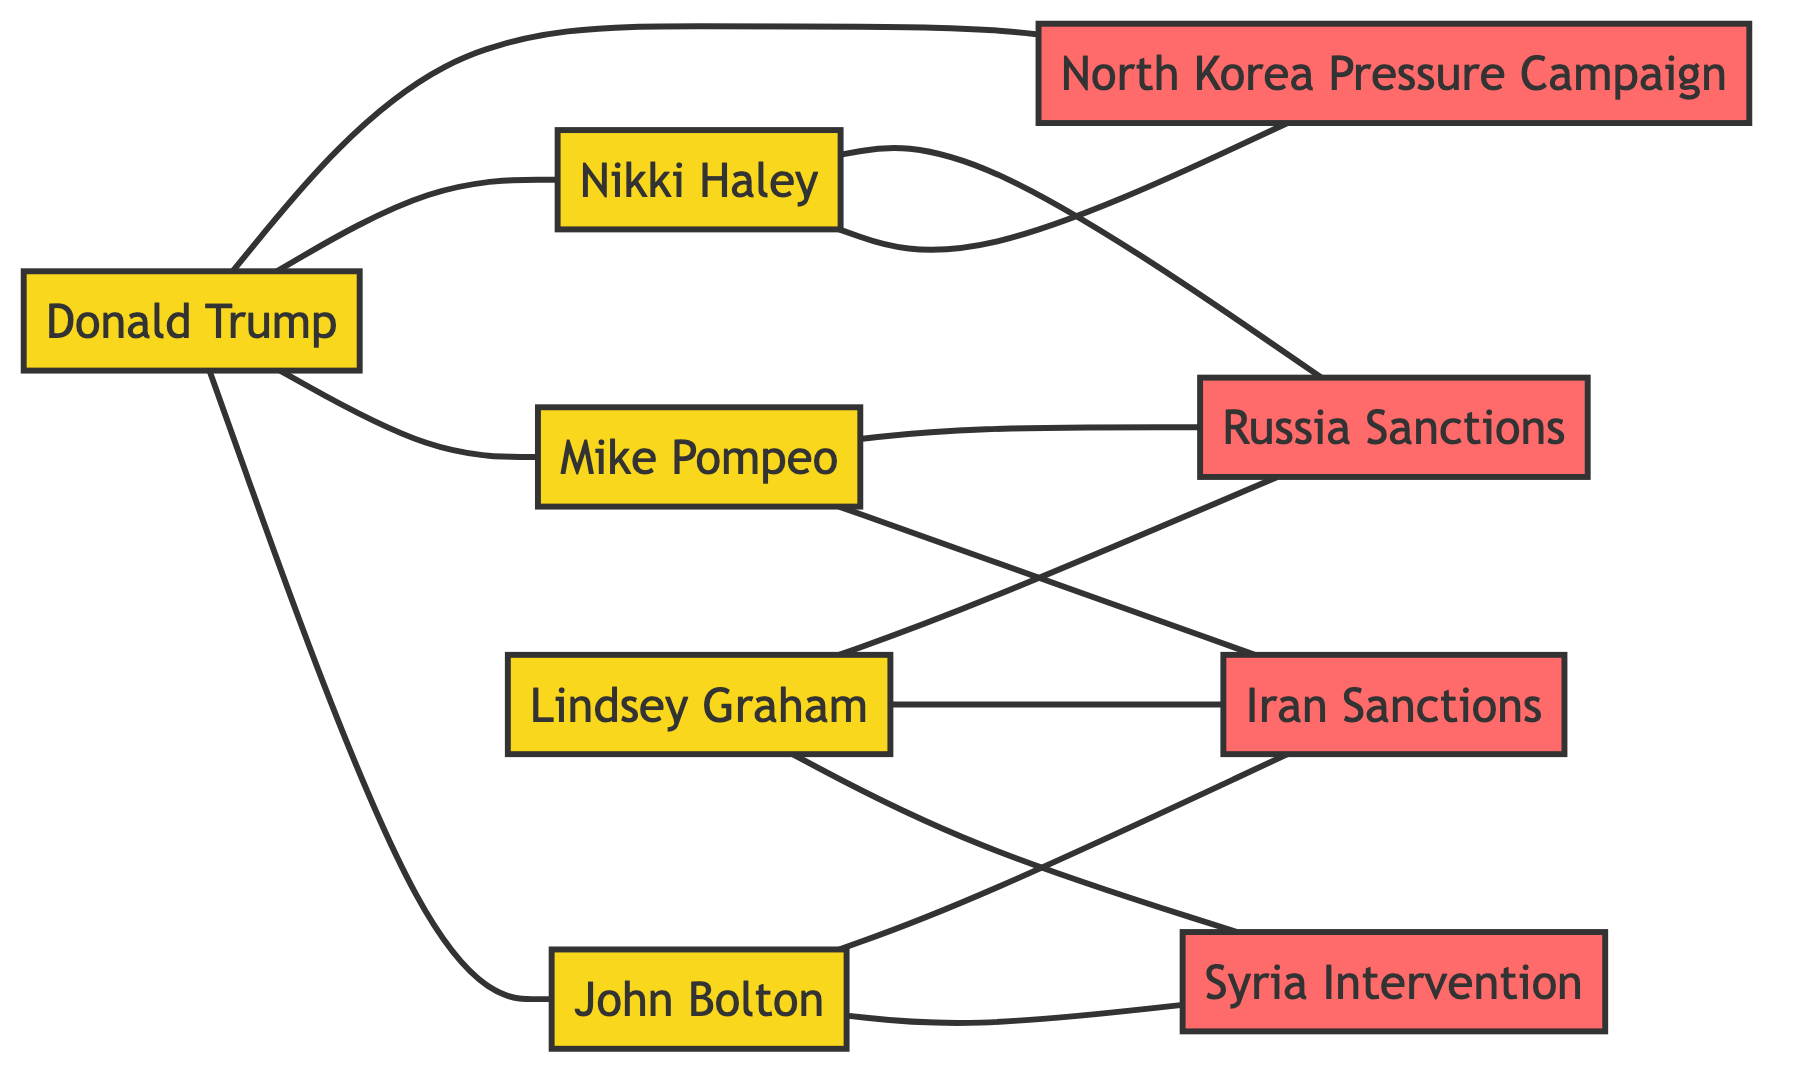What is the total number of nodes in the graph? The graph contains 8 nodes, which are 5 political figures and 3 policy decisions.
Answer: 8 Which political figure was appointed as US Ambassador to the UN? The edge connecting Donald Trump to Nikki Haley indicates that Nikki Haley was appointed as US Ambassador to the UN.
Answer: Nikki Haley How many policy decisions are linked to Lindsey Graham? Lindsey Graham is connected to Syria Intervention, Iran Sanctions, and Russia Sanctions, totaling 3 policy decisions.
Answer: 3 What relationship links John Bolton to the policy decision of Syria Intervention? John Bolton advocated for Syria Intervention, as indicated by the edge from John Bolton to Syria Intervention.
Answer: advocated for Which policy decisions did Mike Pompeo support? Mike Pompeo is linked to two policies: Iran Sanctions and Russia Sanctions, as indicated by the edges connecting him to these policies.
Answer: Iran Sanctions, Russia Sanctions Who initiated the North Korea Pressure Campaign? The edge connecting Donald Trump to North Korea Pressure Campaign indicates that Donald Trump initiated this policy.
Answer: Donald Trump Which policy did both Nikki Haley and Lindsey Graham endorse? The policy of Russia Sanctions is endorsed by both Nikki Haley and Lindsey Graham, as shown by their connections to this policy.
Answer: Russia Sanctions Which political figure is linked to the most policies in the diagram? John Bolton is linked to 3 policies: Syria Intervention, Iran Sanctions, and is associated indirectly with others through connections.
Answer: John Bolton Which policies did Lindsey Graham support? Lindsey Graham is connected to Syria Intervention, Iran Sanctions, and Russia Sanctions, indicating his support for all three.
Answer: Syria Intervention, Iran Sanctions, Russia Sanctions 